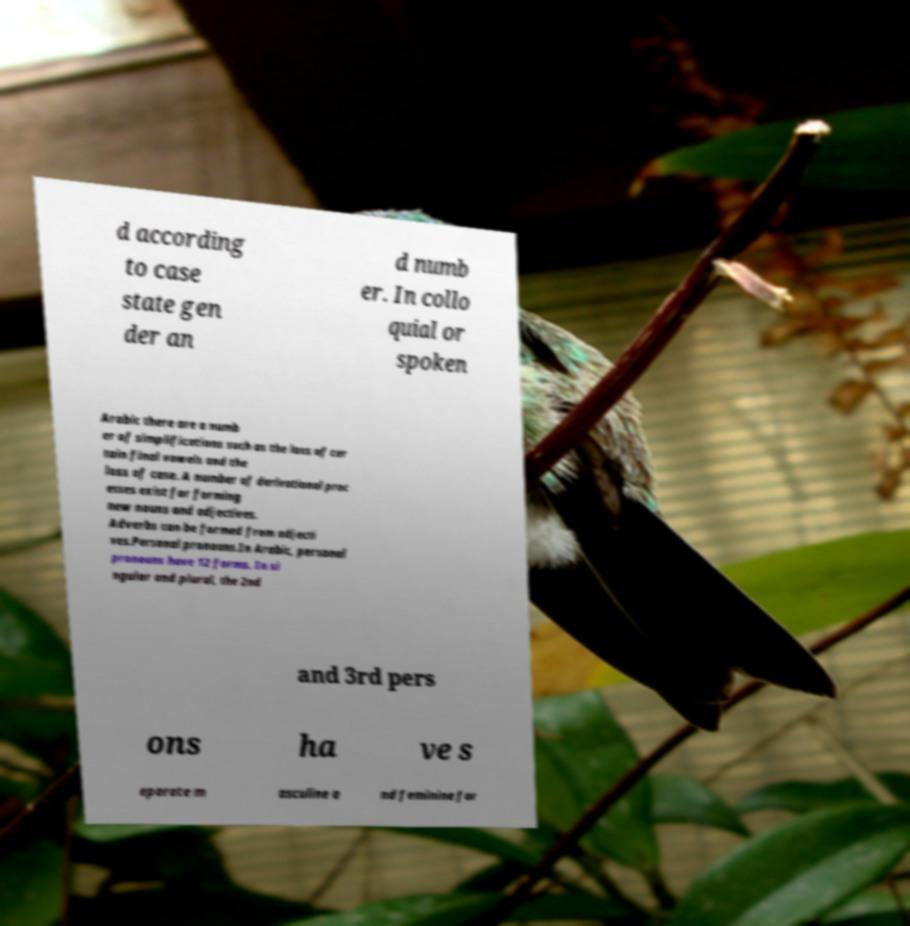Could you extract and type out the text from this image? d according to case state gen der an d numb er. In collo quial or spoken Arabic there are a numb er of simplifications such as the loss of cer tain final vowels and the loss of case. A number of derivational proc esses exist for forming new nouns and adjectives. Adverbs can be formed from adjecti ves.Personal pronouns.In Arabic, personal pronouns have 12 forms. In si ngular and plural, the 2nd and 3rd pers ons ha ve s eparate m asculine a nd feminine for 